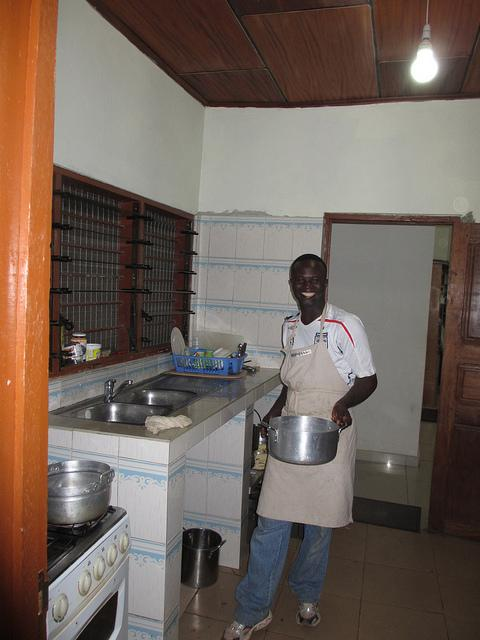This man is in a similar profession to what character? Please explain your reasoning. chef boyardee. The person is holding a pot in a kitchen setting which likely means his profession is in cooking which would be similar to answer a. 